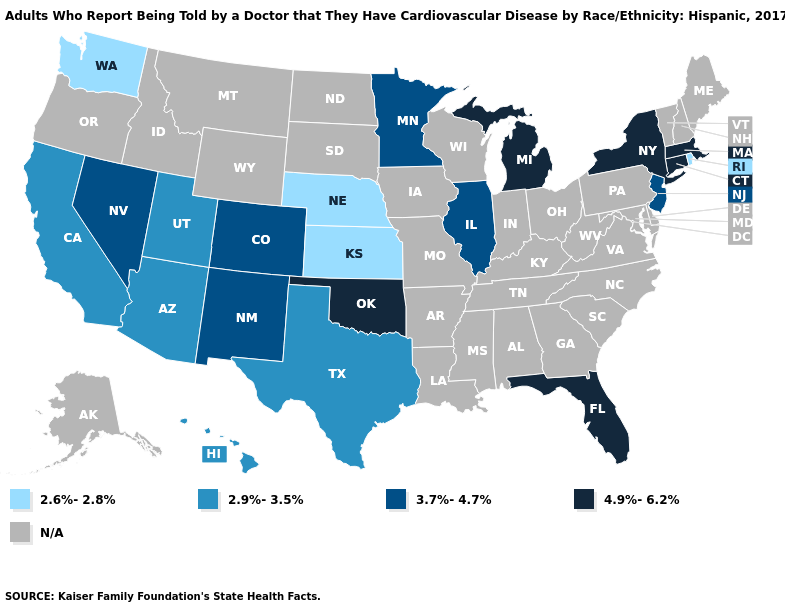Among the states that border Ohio , which have the highest value?
Keep it brief. Michigan. Name the states that have a value in the range 4.9%-6.2%?
Short answer required. Connecticut, Florida, Massachusetts, Michigan, New York, Oklahoma. What is the lowest value in states that border Wyoming?
Give a very brief answer. 2.6%-2.8%. Does Texas have the highest value in the USA?
Short answer required. No. Among the states that border Arizona , does New Mexico have the highest value?
Answer briefly. Yes. Name the states that have a value in the range N/A?
Write a very short answer. Alabama, Alaska, Arkansas, Delaware, Georgia, Idaho, Indiana, Iowa, Kentucky, Louisiana, Maine, Maryland, Mississippi, Missouri, Montana, New Hampshire, North Carolina, North Dakota, Ohio, Oregon, Pennsylvania, South Carolina, South Dakota, Tennessee, Vermont, Virginia, West Virginia, Wisconsin, Wyoming. Among the states that border Connecticut , which have the highest value?
Give a very brief answer. Massachusetts, New York. What is the value of Massachusetts?
Answer briefly. 4.9%-6.2%. Which states have the highest value in the USA?
Keep it brief. Connecticut, Florida, Massachusetts, Michigan, New York, Oklahoma. Name the states that have a value in the range N/A?
Keep it brief. Alabama, Alaska, Arkansas, Delaware, Georgia, Idaho, Indiana, Iowa, Kentucky, Louisiana, Maine, Maryland, Mississippi, Missouri, Montana, New Hampshire, North Carolina, North Dakota, Ohio, Oregon, Pennsylvania, South Carolina, South Dakota, Tennessee, Vermont, Virginia, West Virginia, Wisconsin, Wyoming. Among the states that border Oregon , does Washington have the lowest value?
Quick response, please. Yes. Name the states that have a value in the range 2.6%-2.8%?
Quick response, please. Kansas, Nebraska, Rhode Island, Washington. Which states have the highest value in the USA?
Short answer required. Connecticut, Florida, Massachusetts, Michigan, New York, Oklahoma. 